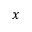Convert formula to latex. <formula><loc_0><loc_0><loc_500><loc_500>x</formula> 